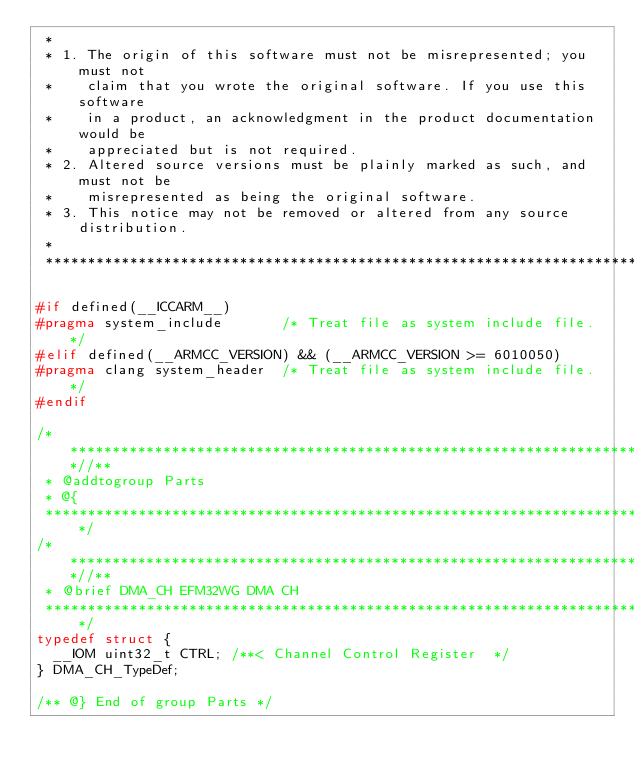<code> <loc_0><loc_0><loc_500><loc_500><_C_> *
 * 1. The origin of this software must not be misrepresented; you must not
 *    claim that you wrote the original software. If you use this software
 *    in a product, an acknowledgment in the product documentation would be
 *    appreciated but is not required.
 * 2. Altered source versions must be plainly marked as such, and must not be
 *    misrepresented as being the original software.
 * 3. This notice may not be removed or altered from any source distribution.
 *
 ******************************************************************************/

#if defined(__ICCARM__)
#pragma system_include       /* Treat file as system include file. */
#elif defined(__ARMCC_VERSION) && (__ARMCC_VERSION >= 6010050)
#pragma clang system_header  /* Treat file as system include file. */
#endif

/***************************************************************************//**
 * @addtogroup Parts
 * @{
 ******************************************************************************/
/***************************************************************************//**
 * @brief DMA_CH EFM32WG DMA CH
 ******************************************************************************/
typedef struct {
  __IOM uint32_t CTRL; /**< Channel Control Register  */
} DMA_CH_TypeDef;

/** @} End of group Parts */
</code> 